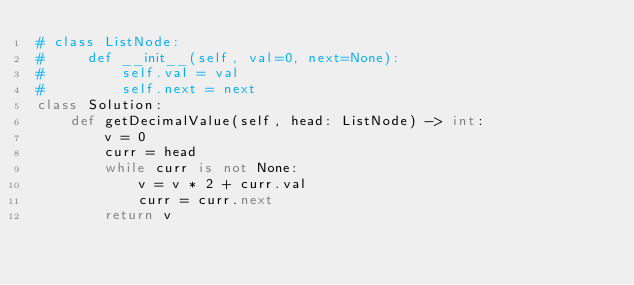Convert code to text. <code><loc_0><loc_0><loc_500><loc_500><_Python_># class ListNode:
#     def __init__(self, val=0, next=None):
#         self.val = val
#         self.next = next
class Solution:
    def getDecimalValue(self, head: ListNode) -> int:
        v = 0
        curr = head
        while curr is not None:
            v = v * 2 + curr.val
            curr = curr.next
        return v</code> 